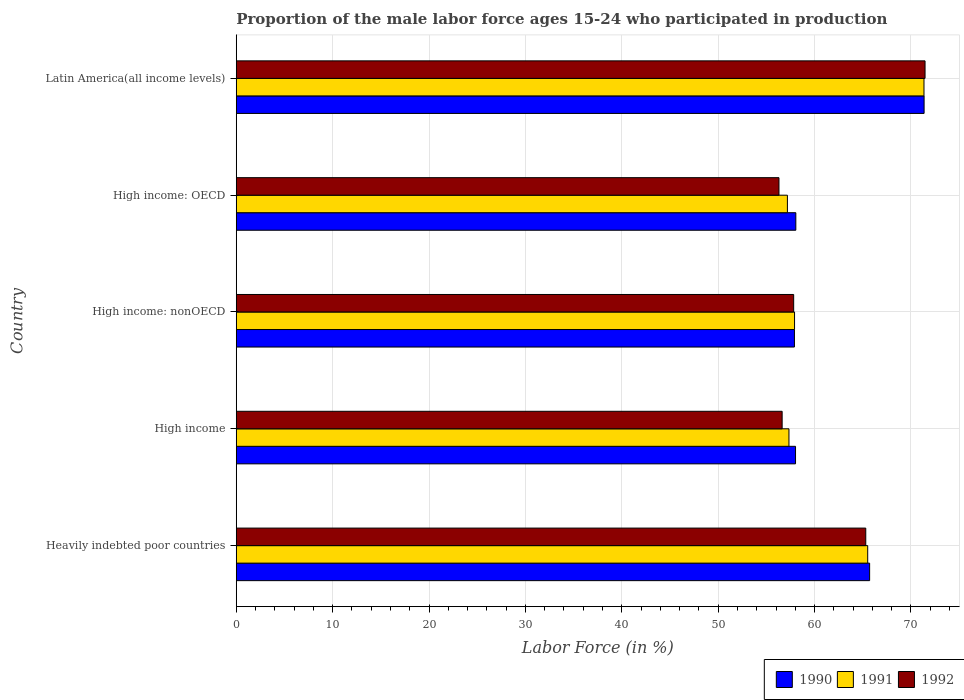How many different coloured bars are there?
Offer a terse response. 3. How many groups of bars are there?
Make the answer very short. 5. Are the number of bars on each tick of the Y-axis equal?
Your answer should be very brief. Yes. How many bars are there on the 1st tick from the top?
Provide a succinct answer. 3. What is the label of the 3rd group of bars from the top?
Provide a succinct answer. High income: nonOECD. In how many cases, is the number of bars for a given country not equal to the number of legend labels?
Give a very brief answer. 0. What is the proportion of the male labor force who participated in production in 1992 in High income?
Keep it short and to the point. 56.64. Across all countries, what is the maximum proportion of the male labor force who participated in production in 1991?
Provide a succinct answer. 71.35. Across all countries, what is the minimum proportion of the male labor force who participated in production in 1990?
Give a very brief answer. 57.91. In which country was the proportion of the male labor force who participated in production in 1991 maximum?
Provide a succinct answer. Latin America(all income levels). In which country was the proportion of the male labor force who participated in production in 1992 minimum?
Offer a very short reply. High income: OECD. What is the total proportion of the male labor force who participated in production in 1991 in the graph?
Your response must be concise. 309.31. What is the difference between the proportion of the male labor force who participated in production in 1992 in Heavily indebted poor countries and that in High income?
Keep it short and to the point. 8.68. What is the difference between the proportion of the male labor force who participated in production in 1990 in High income and the proportion of the male labor force who participated in production in 1992 in High income: nonOECD?
Your response must be concise. 0.19. What is the average proportion of the male labor force who participated in production in 1990 per country?
Provide a succinct answer. 62.21. What is the difference between the proportion of the male labor force who participated in production in 1990 and proportion of the male labor force who participated in production in 1991 in High income: OECD?
Give a very brief answer. 0.87. In how many countries, is the proportion of the male labor force who participated in production in 1990 greater than 50 %?
Ensure brevity in your answer.  5. What is the ratio of the proportion of the male labor force who participated in production in 1990 in Heavily indebted poor countries to that in High income?
Offer a terse response. 1.13. Is the difference between the proportion of the male labor force who participated in production in 1990 in Heavily indebted poor countries and High income greater than the difference between the proportion of the male labor force who participated in production in 1991 in Heavily indebted poor countries and High income?
Ensure brevity in your answer.  No. What is the difference between the highest and the second highest proportion of the male labor force who participated in production in 1991?
Provide a short and direct response. 5.84. What is the difference between the highest and the lowest proportion of the male labor force who participated in production in 1992?
Make the answer very short. 15.16. Is the sum of the proportion of the male labor force who participated in production in 1992 in High income and High income: nonOECD greater than the maximum proportion of the male labor force who participated in production in 1991 across all countries?
Give a very brief answer. Yes. What does the 1st bar from the bottom in High income: nonOECD represents?
Ensure brevity in your answer.  1990. How many bars are there?
Provide a succinct answer. 15. Are all the bars in the graph horizontal?
Ensure brevity in your answer.  Yes. What is the difference between two consecutive major ticks on the X-axis?
Ensure brevity in your answer.  10. Are the values on the major ticks of X-axis written in scientific E-notation?
Keep it short and to the point. No. Does the graph contain any zero values?
Provide a short and direct response. No. Does the graph contain grids?
Offer a terse response. Yes. How many legend labels are there?
Keep it short and to the point. 3. What is the title of the graph?
Ensure brevity in your answer.  Proportion of the male labor force ages 15-24 who participated in production. Does "1980" appear as one of the legend labels in the graph?
Your answer should be very brief. No. What is the label or title of the X-axis?
Your answer should be very brief. Labor Force (in %). What is the Labor Force (in %) in 1990 in Heavily indebted poor countries?
Your answer should be compact. 65.71. What is the Labor Force (in %) in 1991 in Heavily indebted poor countries?
Ensure brevity in your answer.  65.51. What is the Labor Force (in %) of 1992 in Heavily indebted poor countries?
Your response must be concise. 65.31. What is the Labor Force (in %) in 1990 in High income?
Provide a short and direct response. 58.03. What is the Labor Force (in %) in 1991 in High income?
Keep it short and to the point. 57.34. What is the Labor Force (in %) of 1992 in High income?
Provide a short and direct response. 56.64. What is the Labor Force (in %) in 1990 in High income: nonOECD?
Offer a terse response. 57.91. What is the Labor Force (in %) in 1991 in High income: nonOECD?
Provide a short and direct response. 57.92. What is the Labor Force (in %) in 1992 in High income: nonOECD?
Offer a very short reply. 57.83. What is the Labor Force (in %) of 1990 in High income: OECD?
Make the answer very short. 58.06. What is the Labor Force (in %) of 1991 in High income: OECD?
Give a very brief answer. 57.18. What is the Labor Force (in %) in 1992 in High income: OECD?
Offer a very short reply. 56.31. What is the Labor Force (in %) in 1990 in Latin America(all income levels)?
Your response must be concise. 71.36. What is the Labor Force (in %) of 1991 in Latin America(all income levels)?
Offer a very short reply. 71.35. What is the Labor Force (in %) of 1992 in Latin America(all income levels)?
Offer a terse response. 71.46. Across all countries, what is the maximum Labor Force (in %) of 1990?
Your answer should be compact. 71.36. Across all countries, what is the maximum Labor Force (in %) in 1991?
Your answer should be very brief. 71.35. Across all countries, what is the maximum Labor Force (in %) in 1992?
Your answer should be very brief. 71.46. Across all countries, what is the minimum Labor Force (in %) of 1990?
Offer a very short reply. 57.91. Across all countries, what is the minimum Labor Force (in %) in 1991?
Keep it short and to the point. 57.18. Across all countries, what is the minimum Labor Force (in %) of 1992?
Offer a very short reply. 56.31. What is the total Labor Force (in %) of 1990 in the graph?
Provide a short and direct response. 311.07. What is the total Labor Force (in %) of 1991 in the graph?
Offer a very short reply. 309.31. What is the total Labor Force (in %) of 1992 in the graph?
Your answer should be very brief. 307.55. What is the difference between the Labor Force (in %) of 1990 in Heavily indebted poor countries and that in High income?
Keep it short and to the point. 7.69. What is the difference between the Labor Force (in %) of 1991 in Heavily indebted poor countries and that in High income?
Your answer should be compact. 8.17. What is the difference between the Labor Force (in %) in 1992 in Heavily indebted poor countries and that in High income?
Provide a succinct answer. 8.68. What is the difference between the Labor Force (in %) of 1990 in Heavily indebted poor countries and that in High income: nonOECD?
Keep it short and to the point. 7.8. What is the difference between the Labor Force (in %) in 1991 in Heavily indebted poor countries and that in High income: nonOECD?
Offer a terse response. 7.59. What is the difference between the Labor Force (in %) of 1992 in Heavily indebted poor countries and that in High income: nonOECD?
Provide a succinct answer. 7.48. What is the difference between the Labor Force (in %) of 1990 in Heavily indebted poor countries and that in High income: OECD?
Offer a very short reply. 7.66. What is the difference between the Labor Force (in %) of 1991 in Heavily indebted poor countries and that in High income: OECD?
Your answer should be compact. 8.33. What is the difference between the Labor Force (in %) in 1992 in Heavily indebted poor countries and that in High income: OECD?
Provide a succinct answer. 9.01. What is the difference between the Labor Force (in %) of 1990 in Heavily indebted poor countries and that in Latin America(all income levels)?
Offer a terse response. -5.65. What is the difference between the Labor Force (in %) of 1991 in Heavily indebted poor countries and that in Latin America(all income levels)?
Keep it short and to the point. -5.84. What is the difference between the Labor Force (in %) in 1992 in Heavily indebted poor countries and that in Latin America(all income levels)?
Offer a very short reply. -6.15. What is the difference between the Labor Force (in %) in 1990 in High income and that in High income: nonOECD?
Offer a terse response. 0.11. What is the difference between the Labor Force (in %) in 1991 in High income and that in High income: nonOECD?
Your answer should be very brief. -0.58. What is the difference between the Labor Force (in %) in 1992 in High income and that in High income: nonOECD?
Your answer should be compact. -1.2. What is the difference between the Labor Force (in %) of 1990 in High income and that in High income: OECD?
Your response must be concise. -0.03. What is the difference between the Labor Force (in %) in 1991 in High income and that in High income: OECD?
Your answer should be very brief. 0.16. What is the difference between the Labor Force (in %) in 1992 in High income and that in High income: OECD?
Your answer should be very brief. 0.33. What is the difference between the Labor Force (in %) in 1990 in High income and that in Latin America(all income levels)?
Provide a short and direct response. -13.34. What is the difference between the Labor Force (in %) of 1991 in High income and that in Latin America(all income levels)?
Give a very brief answer. -14.01. What is the difference between the Labor Force (in %) of 1992 in High income and that in Latin America(all income levels)?
Make the answer very short. -14.83. What is the difference between the Labor Force (in %) in 1990 in High income: nonOECD and that in High income: OECD?
Your response must be concise. -0.14. What is the difference between the Labor Force (in %) in 1991 in High income: nonOECD and that in High income: OECD?
Your answer should be very brief. 0.74. What is the difference between the Labor Force (in %) of 1992 in High income: nonOECD and that in High income: OECD?
Offer a very short reply. 1.53. What is the difference between the Labor Force (in %) of 1990 in High income: nonOECD and that in Latin America(all income levels)?
Provide a succinct answer. -13.45. What is the difference between the Labor Force (in %) in 1991 in High income: nonOECD and that in Latin America(all income levels)?
Your response must be concise. -13.43. What is the difference between the Labor Force (in %) in 1992 in High income: nonOECD and that in Latin America(all income levels)?
Your answer should be very brief. -13.63. What is the difference between the Labor Force (in %) in 1990 in High income: OECD and that in Latin America(all income levels)?
Your response must be concise. -13.31. What is the difference between the Labor Force (in %) of 1991 in High income: OECD and that in Latin America(all income levels)?
Provide a succinct answer. -14.17. What is the difference between the Labor Force (in %) of 1992 in High income: OECD and that in Latin America(all income levels)?
Your response must be concise. -15.16. What is the difference between the Labor Force (in %) in 1990 in Heavily indebted poor countries and the Labor Force (in %) in 1991 in High income?
Your response must be concise. 8.37. What is the difference between the Labor Force (in %) of 1990 in Heavily indebted poor countries and the Labor Force (in %) of 1992 in High income?
Provide a short and direct response. 9.08. What is the difference between the Labor Force (in %) in 1991 in Heavily indebted poor countries and the Labor Force (in %) in 1992 in High income?
Your answer should be very brief. 8.88. What is the difference between the Labor Force (in %) of 1990 in Heavily indebted poor countries and the Labor Force (in %) of 1991 in High income: nonOECD?
Provide a succinct answer. 7.79. What is the difference between the Labor Force (in %) of 1990 in Heavily indebted poor countries and the Labor Force (in %) of 1992 in High income: nonOECD?
Offer a very short reply. 7.88. What is the difference between the Labor Force (in %) of 1991 in Heavily indebted poor countries and the Labor Force (in %) of 1992 in High income: nonOECD?
Offer a very short reply. 7.68. What is the difference between the Labor Force (in %) of 1990 in Heavily indebted poor countries and the Labor Force (in %) of 1991 in High income: OECD?
Give a very brief answer. 8.53. What is the difference between the Labor Force (in %) of 1990 in Heavily indebted poor countries and the Labor Force (in %) of 1992 in High income: OECD?
Your answer should be compact. 9.41. What is the difference between the Labor Force (in %) of 1991 in Heavily indebted poor countries and the Labor Force (in %) of 1992 in High income: OECD?
Your response must be concise. 9.21. What is the difference between the Labor Force (in %) in 1990 in Heavily indebted poor countries and the Labor Force (in %) in 1991 in Latin America(all income levels)?
Provide a short and direct response. -5.64. What is the difference between the Labor Force (in %) in 1990 in Heavily indebted poor countries and the Labor Force (in %) in 1992 in Latin America(all income levels)?
Make the answer very short. -5.75. What is the difference between the Labor Force (in %) of 1991 in Heavily indebted poor countries and the Labor Force (in %) of 1992 in Latin America(all income levels)?
Ensure brevity in your answer.  -5.95. What is the difference between the Labor Force (in %) in 1990 in High income and the Labor Force (in %) in 1991 in High income: nonOECD?
Ensure brevity in your answer.  0.1. What is the difference between the Labor Force (in %) in 1990 in High income and the Labor Force (in %) in 1992 in High income: nonOECD?
Provide a short and direct response. 0.19. What is the difference between the Labor Force (in %) in 1991 in High income and the Labor Force (in %) in 1992 in High income: nonOECD?
Give a very brief answer. -0.49. What is the difference between the Labor Force (in %) in 1990 in High income and the Labor Force (in %) in 1991 in High income: OECD?
Offer a very short reply. 0.84. What is the difference between the Labor Force (in %) of 1990 in High income and the Labor Force (in %) of 1992 in High income: OECD?
Keep it short and to the point. 1.72. What is the difference between the Labor Force (in %) in 1991 in High income and the Labor Force (in %) in 1992 in High income: OECD?
Make the answer very short. 1.04. What is the difference between the Labor Force (in %) of 1990 in High income and the Labor Force (in %) of 1991 in Latin America(all income levels)?
Ensure brevity in your answer.  -13.33. What is the difference between the Labor Force (in %) in 1990 in High income and the Labor Force (in %) in 1992 in Latin America(all income levels)?
Provide a succinct answer. -13.44. What is the difference between the Labor Force (in %) of 1991 in High income and the Labor Force (in %) of 1992 in Latin America(all income levels)?
Keep it short and to the point. -14.12. What is the difference between the Labor Force (in %) of 1990 in High income: nonOECD and the Labor Force (in %) of 1991 in High income: OECD?
Offer a very short reply. 0.73. What is the difference between the Labor Force (in %) in 1990 in High income: nonOECD and the Labor Force (in %) in 1992 in High income: OECD?
Your response must be concise. 1.61. What is the difference between the Labor Force (in %) of 1991 in High income: nonOECD and the Labor Force (in %) of 1992 in High income: OECD?
Ensure brevity in your answer.  1.62. What is the difference between the Labor Force (in %) of 1990 in High income: nonOECD and the Labor Force (in %) of 1991 in Latin America(all income levels)?
Provide a succinct answer. -13.44. What is the difference between the Labor Force (in %) in 1990 in High income: nonOECD and the Labor Force (in %) in 1992 in Latin America(all income levels)?
Your answer should be very brief. -13.55. What is the difference between the Labor Force (in %) in 1991 in High income: nonOECD and the Labor Force (in %) in 1992 in Latin America(all income levels)?
Your answer should be very brief. -13.54. What is the difference between the Labor Force (in %) of 1990 in High income: OECD and the Labor Force (in %) of 1991 in Latin America(all income levels)?
Your answer should be very brief. -13.3. What is the difference between the Labor Force (in %) of 1990 in High income: OECD and the Labor Force (in %) of 1992 in Latin America(all income levels)?
Ensure brevity in your answer.  -13.41. What is the difference between the Labor Force (in %) of 1991 in High income: OECD and the Labor Force (in %) of 1992 in Latin America(all income levels)?
Offer a terse response. -14.28. What is the average Labor Force (in %) of 1990 per country?
Give a very brief answer. 62.21. What is the average Labor Force (in %) in 1991 per country?
Make the answer very short. 61.86. What is the average Labor Force (in %) in 1992 per country?
Your answer should be compact. 61.51. What is the difference between the Labor Force (in %) of 1990 and Labor Force (in %) of 1991 in Heavily indebted poor countries?
Offer a very short reply. 0.2. What is the difference between the Labor Force (in %) in 1990 and Labor Force (in %) in 1992 in Heavily indebted poor countries?
Provide a short and direct response. 0.4. What is the difference between the Labor Force (in %) in 1991 and Labor Force (in %) in 1992 in Heavily indebted poor countries?
Your answer should be very brief. 0.2. What is the difference between the Labor Force (in %) of 1990 and Labor Force (in %) of 1991 in High income?
Provide a short and direct response. 0.68. What is the difference between the Labor Force (in %) in 1990 and Labor Force (in %) in 1992 in High income?
Make the answer very short. 1.39. What is the difference between the Labor Force (in %) of 1991 and Labor Force (in %) of 1992 in High income?
Your response must be concise. 0.71. What is the difference between the Labor Force (in %) of 1990 and Labor Force (in %) of 1991 in High income: nonOECD?
Provide a short and direct response. -0.01. What is the difference between the Labor Force (in %) in 1990 and Labor Force (in %) in 1992 in High income: nonOECD?
Provide a succinct answer. 0.08. What is the difference between the Labor Force (in %) in 1991 and Labor Force (in %) in 1992 in High income: nonOECD?
Offer a terse response. 0.09. What is the difference between the Labor Force (in %) in 1990 and Labor Force (in %) in 1991 in High income: OECD?
Keep it short and to the point. 0.87. What is the difference between the Labor Force (in %) in 1990 and Labor Force (in %) in 1992 in High income: OECD?
Your answer should be compact. 1.75. What is the difference between the Labor Force (in %) in 1991 and Labor Force (in %) in 1992 in High income: OECD?
Provide a short and direct response. 0.88. What is the difference between the Labor Force (in %) of 1990 and Labor Force (in %) of 1991 in Latin America(all income levels)?
Your answer should be very brief. 0.01. What is the difference between the Labor Force (in %) of 1990 and Labor Force (in %) of 1992 in Latin America(all income levels)?
Provide a succinct answer. -0.1. What is the difference between the Labor Force (in %) of 1991 and Labor Force (in %) of 1992 in Latin America(all income levels)?
Provide a short and direct response. -0.11. What is the ratio of the Labor Force (in %) of 1990 in Heavily indebted poor countries to that in High income?
Offer a very short reply. 1.13. What is the ratio of the Labor Force (in %) of 1991 in Heavily indebted poor countries to that in High income?
Give a very brief answer. 1.14. What is the ratio of the Labor Force (in %) of 1992 in Heavily indebted poor countries to that in High income?
Make the answer very short. 1.15. What is the ratio of the Labor Force (in %) in 1990 in Heavily indebted poor countries to that in High income: nonOECD?
Offer a very short reply. 1.13. What is the ratio of the Labor Force (in %) in 1991 in Heavily indebted poor countries to that in High income: nonOECD?
Provide a short and direct response. 1.13. What is the ratio of the Labor Force (in %) of 1992 in Heavily indebted poor countries to that in High income: nonOECD?
Your answer should be compact. 1.13. What is the ratio of the Labor Force (in %) of 1990 in Heavily indebted poor countries to that in High income: OECD?
Your answer should be very brief. 1.13. What is the ratio of the Labor Force (in %) of 1991 in Heavily indebted poor countries to that in High income: OECD?
Provide a short and direct response. 1.15. What is the ratio of the Labor Force (in %) of 1992 in Heavily indebted poor countries to that in High income: OECD?
Your response must be concise. 1.16. What is the ratio of the Labor Force (in %) in 1990 in Heavily indebted poor countries to that in Latin America(all income levels)?
Your answer should be very brief. 0.92. What is the ratio of the Labor Force (in %) of 1991 in Heavily indebted poor countries to that in Latin America(all income levels)?
Offer a very short reply. 0.92. What is the ratio of the Labor Force (in %) in 1992 in Heavily indebted poor countries to that in Latin America(all income levels)?
Your answer should be compact. 0.91. What is the ratio of the Labor Force (in %) of 1991 in High income to that in High income: nonOECD?
Ensure brevity in your answer.  0.99. What is the ratio of the Labor Force (in %) in 1992 in High income to that in High income: nonOECD?
Give a very brief answer. 0.98. What is the ratio of the Labor Force (in %) of 1990 in High income to that in High income: OECD?
Offer a terse response. 1. What is the ratio of the Labor Force (in %) of 1992 in High income to that in High income: OECD?
Ensure brevity in your answer.  1.01. What is the ratio of the Labor Force (in %) in 1990 in High income to that in Latin America(all income levels)?
Your response must be concise. 0.81. What is the ratio of the Labor Force (in %) in 1991 in High income to that in Latin America(all income levels)?
Offer a very short reply. 0.8. What is the ratio of the Labor Force (in %) in 1992 in High income to that in Latin America(all income levels)?
Your answer should be very brief. 0.79. What is the ratio of the Labor Force (in %) of 1990 in High income: nonOECD to that in High income: OECD?
Your response must be concise. 1. What is the ratio of the Labor Force (in %) in 1991 in High income: nonOECD to that in High income: OECD?
Provide a succinct answer. 1.01. What is the ratio of the Labor Force (in %) of 1992 in High income: nonOECD to that in High income: OECD?
Your response must be concise. 1.03. What is the ratio of the Labor Force (in %) of 1990 in High income: nonOECD to that in Latin America(all income levels)?
Provide a succinct answer. 0.81. What is the ratio of the Labor Force (in %) of 1991 in High income: nonOECD to that in Latin America(all income levels)?
Keep it short and to the point. 0.81. What is the ratio of the Labor Force (in %) of 1992 in High income: nonOECD to that in Latin America(all income levels)?
Offer a terse response. 0.81. What is the ratio of the Labor Force (in %) in 1990 in High income: OECD to that in Latin America(all income levels)?
Ensure brevity in your answer.  0.81. What is the ratio of the Labor Force (in %) in 1991 in High income: OECD to that in Latin America(all income levels)?
Offer a terse response. 0.8. What is the ratio of the Labor Force (in %) of 1992 in High income: OECD to that in Latin America(all income levels)?
Make the answer very short. 0.79. What is the difference between the highest and the second highest Labor Force (in %) of 1990?
Ensure brevity in your answer.  5.65. What is the difference between the highest and the second highest Labor Force (in %) of 1991?
Your answer should be very brief. 5.84. What is the difference between the highest and the second highest Labor Force (in %) in 1992?
Offer a terse response. 6.15. What is the difference between the highest and the lowest Labor Force (in %) of 1990?
Give a very brief answer. 13.45. What is the difference between the highest and the lowest Labor Force (in %) of 1991?
Ensure brevity in your answer.  14.17. What is the difference between the highest and the lowest Labor Force (in %) of 1992?
Provide a succinct answer. 15.16. 